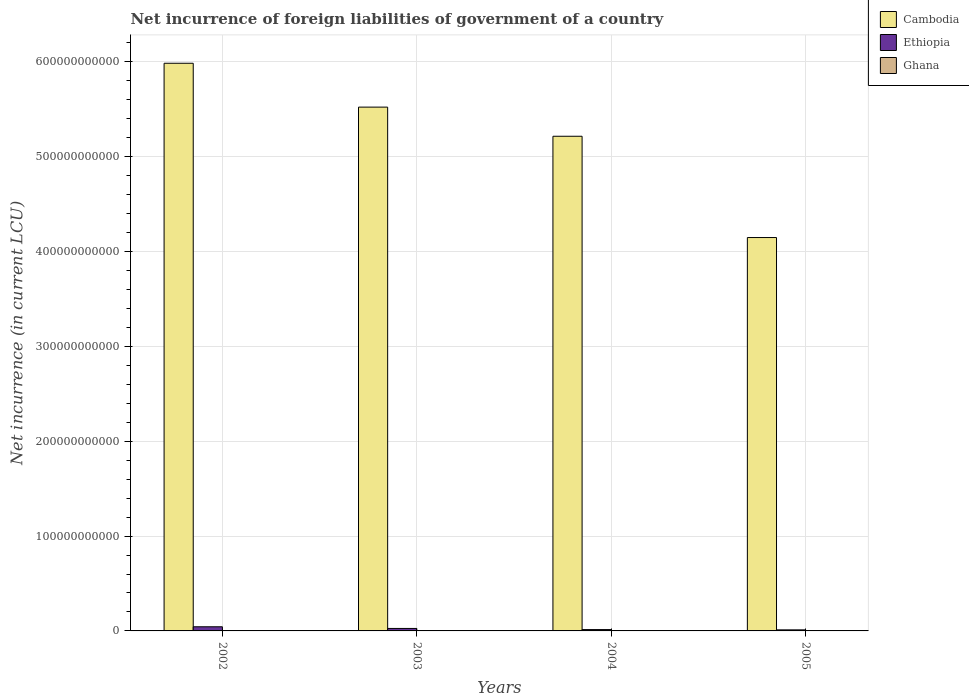What is the net incurrence of foreign liabilities in Ghana in 2003?
Ensure brevity in your answer.  2.17e+08. Across all years, what is the maximum net incurrence of foreign liabilities in Ethiopia?
Provide a short and direct response. 4.38e+09. Across all years, what is the minimum net incurrence of foreign liabilities in Ghana?
Provide a succinct answer. 4.61e+07. In which year was the net incurrence of foreign liabilities in Ghana maximum?
Offer a very short reply. 2005. What is the total net incurrence of foreign liabilities in Cambodia in the graph?
Give a very brief answer. 2.09e+12. What is the difference between the net incurrence of foreign liabilities in Cambodia in 2003 and that in 2004?
Provide a short and direct response. 3.07e+1. What is the difference between the net incurrence of foreign liabilities in Cambodia in 2003 and the net incurrence of foreign liabilities in Ghana in 2002?
Your response must be concise. 5.52e+11. What is the average net incurrence of foreign liabilities in Ethiopia per year?
Your answer should be compact. 2.38e+09. In the year 2002, what is the difference between the net incurrence of foreign liabilities in Ethiopia and net incurrence of foreign liabilities in Ghana?
Provide a succinct answer. 4.33e+09. In how many years, is the net incurrence of foreign liabilities in Ghana greater than 480000000000 LCU?
Offer a very short reply. 0. What is the ratio of the net incurrence of foreign liabilities in Ethiopia in 2002 to that in 2005?
Offer a terse response. 3.95. Is the net incurrence of foreign liabilities in Cambodia in 2003 less than that in 2005?
Make the answer very short. No. What is the difference between the highest and the second highest net incurrence of foreign liabilities in Cambodia?
Offer a very short reply. 4.62e+1. What is the difference between the highest and the lowest net incurrence of foreign liabilities in Ghana?
Ensure brevity in your answer.  1.99e+08. In how many years, is the net incurrence of foreign liabilities in Ghana greater than the average net incurrence of foreign liabilities in Ghana taken over all years?
Offer a very short reply. 2. Is the sum of the net incurrence of foreign liabilities in Ethiopia in 2003 and 2005 greater than the maximum net incurrence of foreign liabilities in Cambodia across all years?
Offer a terse response. No. What does the 3rd bar from the right in 2003 represents?
Offer a terse response. Cambodia. How many years are there in the graph?
Offer a very short reply. 4. What is the difference between two consecutive major ticks on the Y-axis?
Provide a succinct answer. 1.00e+11. Are the values on the major ticks of Y-axis written in scientific E-notation?
Make the answer very short. No. Where does the legend appear in the graph?
Give a very brief answer. Top right. How many legend labels are there?
Ensure brevity in your answer.  3. How are the legend labels stacked?
Provide a short and direct response. Vertical. What is the title of the graph?
Provide a short and direct response. Net incurrence of foreign liabilities of government of a country. Does "Moldova" appear as one of the legend labels in the graph?
Give a very brief answer. No. What is the label or title of the Y-axis?
Your answer should be compact. Net incurrence (in current LCU). What is the Net incurrence (in current LCU) of Cambodia in 2002?
Give a very brief answer. 5.98e+11. What is the Net incurrence (in current LCU) of Ethiopia in 2002?
Provide a succinct answer. 4.38e+09. What is the Net incurrence (in current LCU) in Ghana in 2002?
Ensure brevity in your answer.  4.61e+07. What is the Net incurrence (in current LCU) in Cambodia in 2003?
Your answer should be very brief. 5.52e+11. What is the Net incurrence (in current LCU) in Ethiopia in 2003?
Provide a succinct answer. 2.62e+09. What is the Net incurrence (in current LCU) in Ghana in 2003?
Your answer should be compact. 2.17e+08. What is the Net incurrence (in current LCU) of Cambodia in 2004?
Provide a short and direct response. 5.21e+11. What is the Net incurrence (in current LCU) in Ethiopia in 2004?
Provide a succinct answer. 1.40e+09. What is the Net incurrence (in current LCU) in Ghana in 2004?
Offer a terse response. 1.49e+08. What is the Net incurrence (in current LCU) in Cambodia in 2005?
Offer a very short reply. 4.15e+11. What is the Net incurrence (in current LCU) of Ethiopia in 2005?
Your answer should be very brief. 1.11e+09. What is the Net incurrence (in current LCU) in Ghana in 2005?
Your response must be concise. 2.45e+08. Across all years, what is the maximum Net incurrence (in current LCU) in Cambodia?
Your answer should be compact. 5.98e+11. Across all years, what is the maximum Net incurrence (in current LCU) of Ethiopia?
Make the answer very short. 4.38e+09. Across all years, what is the maximum Net incurrence (in current LCU) of Ghana?
Offer a very short reply. 2.45e+08. Across all years, what is the minimum Net incurrence (in current LCU) of Cambodia?
Your answer should be very brief. 4.15e+11. Across all years, what is the minimum Net incurrence (in current LCU) of Ethiopia?
Ensure brevity in your answer.  1.11e+09. Across all years, what is the minimum Net incurrence (in current LCU) of Ghana?
Your answer should be compact. 4.61e+07. What is the total Net incurrence (in current LCU) in Cambodia in the graph?
Your response must be concise. 2.09e+12. What is the total Net incurrence (in current LCU) of Ethiopia in the graph?
Your response must be concise. 9.50e+09. What is the total Net incurrence (in current LCU) of Ghana in the graph?
Provide a succinct answer. 6.57e+08. What is the difference between the Net incurrence (in current LCU) in Cambodia in 2002 and that in 2003?
Keep it short and to the point. 4.62e+1. What is the difference between the Net incurrence (in current LCU) of Ethiopia in 2002 and that in 2003?
Your answer should be very brief. 1.76e+09. What is the difference between the Net incurrence (in current LCU) in Ghana in 2002 and that in 2003?
Your answer should be compact. -1.71e+08. What is the difference between the Net incurrence (in current LCU) of Cambodia in 2002 and that in 2004?
Ensure brevity in your answer.  7.70e+1. What is the difference between the Net incurrence (in current LCU) in Ethiopia in 2002 and that in 2004?
Make the answer very short. 2.97e+09. What is the difference between the Net incurrence (in current LCU) in Ghana in 2002 and that in 2004?
Keep it short and to the point. -1.02e+08. What is the difference between the Net incurrence (in current LCU) in Cambodia in 2002 and that in 2005?
Provide a succinct answer. 1.84e+11. What is the difference between the Net incurrence (in current LCU) of Ethiopia in 2002 and that in 2005?
Make the answer very short. 3.27e+09. What is the difference between the Net incurrence (in current LCU) in Ghana in 2002 and that in 2005?
Ensure brevity in your answer.  -1.99e+08. What is the difference between the Net incurrence (in current LCU) in Cambodia in 2003 and that in 2004?
Keep it short and to the point. 3.07e+1. What is the difference between the Net incurrence (in current LCU) in Ethiopia in 2003 and that in 2004?
Your answer should be compact. 1.21e+09. What is the difference between the Net incurrence (in current LCU) of Ghana in 2003 and that in 2004?
Offer a terse response. 6.89e+07. What is the difference between the Net incurrence (in current LCU) of Cambodia in 2003 and that in 2005?
Make the answer very short. 1.37e+11. What is the difference between the Net incurrence (in current LCU) in Ethiopia in 2003 and that in 2005?
Ensure brevity in your answer.  1.51e+09. What is the difference between the Net incurrence (in current LCU) in Ghana in 2003 and that in 2005?
Offer a terse response. -2.72e+07. What is the difference between the Net incurrence (in current LCU) in Cambodia in 2004 and that in 2005?
Your response must be concise. 1.07e+11. What is the difference between the Net incurrence (in current LCU) in Ethiopia in 2004 and that in 2005?
Keep it short and to the point. 2.96e+08. What is the difference between the Net incurrence (in current LCU) of Ghana in 2004 and that in 2005?
Keep it short and to the point. -9.61e+07. What is the difference between the Net incurrence (in current LCU) of Cambodia in 2002 and the Net incurrence (in current LCU) of Ethiopia in 2003?
Ensure brevity in your answer.  5.96e+11. What is the difference between the Net incurrence (in current LCU) in Cambodia in 2002 and the Net incurrence (in current LCU) in Ghana in 2003?
Give a very brief answer. 5.98e+11. What is the difference between the Net incurrence (in current LCU) of Ethiopia in 2002 and the Net incurrence (in current LCU) of Ghana in 2003?
Give a very brief answer. 4.16e+09. What is the difference between the Net incurrence (in current LCU) of Cambodia in 2002 and the Net incurrence (in current LCU) of Ethiopia in 2004?
Keep it short and to the point. 5.97e+11. What is the difference between the Net incurrence (in current LCU) in Cambodia in 2002 and the Net incurrence (in current LCU) in Ghana in 2004?
Keep it short and to the point. 5.98e+11. What is the difference between the Net incurrence (in current LCU) in Ethiopia in 2002 and the Net incurrence (in current LCU) in Ghana in 2004?
Offer a terse response. 4.23e+09. What is the difference between the Net incurrence (in current LCU) of Cambodia in 2002 and the Net incurrence (in current LCU) of Ethiopia in 2005?
Keep it short and to the point. 5.97e+11. What is the difference between the Net incurrence (in current LCU) in Cambodia in 2002 and the Net incurrence (in current LCU) in Ghana in 2005?
Your answer should be very brief. 5.98e+11. What is the difference between the Net incurrence (in current LCU) of Ethiopia in 2002 and the Net incurrence (in current LCU) of Ghana in 2005?
Your response must be concise. 4.13e+09. What is the difference between the Net incurrence (in current LCU) in Cambodia in 2003 and the Net incurrence (in current LCU) in Ethiopia in 2004?
Make the answer very short. 5.51e+11. What is the difference between the Net incurrence (in current LCU) of Cambodia in 2003 and the Net incurrence (in current LCU) of Ghana in 2004?
Offer a terse response. 5.52e+11. What is the difference between the Net incurrence (in current LCU) in Ethiopia in 2003 and the Net incurrence (in current LCU) in Ghana in 2004?
Ensure brevity in your answer.  2.47e+09. What is the difference between the Net incurrence (in current LCU) of Cambodia in 2003 and the Net incurrence (in current LCU) of Ethiopia in 2005?
Offer a terse response. 5.51e+11. What is the difference between the Net incurrence (in current LCU) of Cambodia in 2003 and the Net incurrence (in current LCU) of Ghana in 2005?
Make the answer very short. 5.52e+11. What is the difference between the Net incurrence (in current LCU) of Ethiopia in 2003 and the Net incurrence (in current LCU) of Ghana in 2005?
Your answer should be very brief. 2.37e+09. What is the difference between the Net incurrence (in current LCU) in Cambodia in 2004 and the Net incurrence (in current LCU) in Ethiopia in 2005?
Keep it short and to the point. 5.20e+11. What is the difference between the Net incurrence (in current LCU) in Cambodia in 2004 and the Net incurrence (in current LCU) in Ghana in 2005?
Your response must be concise. 5.21e+11. What is the difference between the Net incurrence (in current LCU) of Ethiopia in 2004 and the Net incurrence (in current LCU) of Ghana in 2005?
Provide a short and direct response. 1.16e+09. What is the average Net incurrence (in current LCU) of Cambodia per year?
Keep it short and to the point. 5.22e+11. What is the average Net incurrence (in current LCU) of Ethiopia per year?
Offer a very short reply. 2.38e+09. What is the average Net incurrence (in current LCU) in Ghana per year?
Give a very brief answer. 1.64e+08. In the year 2002, what is the difference between the Net incurrence (in current LCU) of Cambodia and Net incurrence (in current LCU) of Ethiopia?
Offer a very short reply. 5.94e+11. In the year 2002, what is the difference between the Net incurrence (in current LCU) in Cambodia and Net incurrence (in current LCU) in Ghana?
Make the answer very short. 5.98e+11. In the year 2002, what is the difference between the Net incurrence (in current LCU) in Ethiopia and Net incurrence (in current LCU) in Ghana?
Give a very brief answer. 4.33e+09. In the year 2003, what is the difference between the Net incurrence (in current LCU) of Cambodia and Net incurrence (in current LCU) of Ethiopia?
Your answer should be compact. 5.50e+11. In the year 2003, what is the difference between the Net incurrence (in current LCU) in Cambodia and Net incurrence (in current LCU) in Ghana?
Offer a very short reply. 5.52e+11. In the year 2003, what is the difference between the Net incurrence (in current LCU) in Ethiopia and Net incurrence (in current LCU) in Ghana?
Offer a terse response. 2.40e+09. In the year 2004, what is the difference between the Net incurrence (in current LCU) of Cambodia and Net incurrence (in current LCU) of Ethiopia?
Make the answer very short. 5.20e+11. In the year 2004, what is the difference between the Net incurrence (in current LCU) of Cambodia and Net incurrence (in current LCU) of Ghana?
Ensure brevity in your answer.  5.21e+11. In the year 2004, what is the difference between the Net incurrence (in current LCU) of Ethiopia and Net incurrence (in current LCU) of Ghana?
Offer a terse response. 1.25e+09. In the year 2005, what is the difference between the Net incurrence (in current LCU) of Cambodia and Net incurrence (in current LCU) of Ethiopia?
Keep it short and to the point. 4.14e+11. In the year 2005, what is the difference between the Net incurrence (in current LCU) of Cambodia and Net incurrence (in current LCU) of Ghana?
Provide a short and direct response. 4.14e+11. In the year 2005, what is the difference between the Net incurrence (in current LCU) in Ethiopia and Net incurrence (in current LCU) in Ghana?
Offer a terse response. 8.63e+08. What is the ratio of the Net incurrence (in current LCU) of Cambodia in 2002 to that in 2003?
Keep it short and to the point. 1.08. What is the ratio of the Net incurrence (in current LCU) of Ethiopia in 2002 to that in 2003?
Provide a succinct answer. 1.67. What is the ratio of the Net incurrence (in current LCU) in Ghana in 2002 to that in 2003?
Offer a terse response. 0.21. What is the ratio of the Net incurrence (in current LCU) of Cambodia in 2002 to that in 2004?
Your answer should be compact. 1.15. What is the ratio of the Net incurrence (in current LCU) of Ethiopia in 2002 to that in 2004?
Offer a terse response. 3.12. What is the ratio of the Net incurrence (in current LCU) of Ghana in 2002 to that in 2004?
Your answer should be compact. 0.31. What is the ratio of the Net incurrence (in current LCU) of Cambodia in 2002 to that in 2005?
Your answer should be compact. 1.44. What is the ratio of the Net incurrence (in current LCU) of Ethiopia in 2002 to that in 2005?
Keep it short and to the point. 3.95. What is the ratio of the Net incurrence (in current LCU) in Ghana in 2002 to that in 2005?
Keep it short and to the point. 0.19. What is the ratio of the Net incurrence (in current LCU) of Cambodia in 2003 to that in 2004?
Offer a terse response. 1.06. What is the ratio of the Net incurrence (in current LCU) in Ethiopia in 2003 to that in 2004?
Give a very brief answer. 1.86. What is the ratio of the Net incurrence (in current LCU) in Ghana in 2003 to that in 2004?
Make the answer very short. 1.46. What is the ratio of the Net incurrence (in current LCU) of Cambodia in 2003 to that in 2005?
Your response must be concise. 1.33. What is the ratio of the Net incurrence (in current LCU) in Ethiopia in 2003 to that in 2005?
Make the answer very short. 2.36. What is the ratio of the Net incurrence (in current LCU) in Ghana in 2003 to that in 2005?
Give a very brief answer. 0.89. What is the ratio of the Net incurrence (in current LCU) of Cambodia in 2004 to that in 2005?
Provide a short and direct response. 1.26. What is the ratio of the Net incurrence (in current LCU) in Ethiopia in 2004 to that in 2005?
Give a very brief answer. 1.27. What is the ratio of the Net incurrence (in current LCU) in Ghana in 2004 to that in 2005?
Provide a short and direct response. 0.61. What is the difference between the highest and the second highest Net incurrence (in current LCU) in Cambodia?
Make the answer very short. 4.62e+1. What is the difference between the highest and the second highest Net incurrence (in current LCU) of Ethiopia?
Provide a succinct answer. 1.76e+09. What is the difference between the highest and the second highest Net incurrence (in current LCU) of Ghana?
Provide a short and direct response. 2.72e+07. What is the difference between the highest and the lowest Net incurrence (in current LCU) in Cambodia?
Give a very brief answer. 1.84e+11. What is the difference between the highest and the lowest Net incurrence (in current LCU) in Ethiopia?
Ensure brevity in your answer.  3.27e+09. What is the difference between the highest and the lowest Net incurrence (in current LCU) in Ghana?
Your answer should be compact. 1.99e+08. 